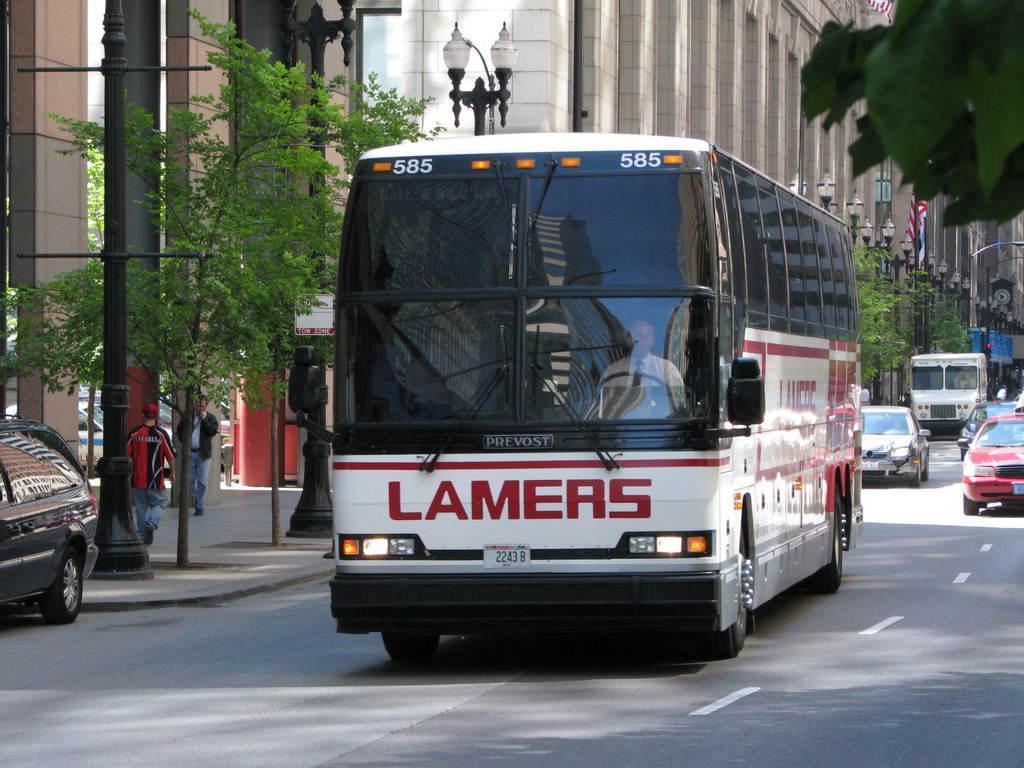Could you give a brief overview of what you see in this image? In this image I can see a road , on the road I can see a buses and cars , beside the road there is a building, trees, street light pole, I can see a person in side the bus in the foreground. 